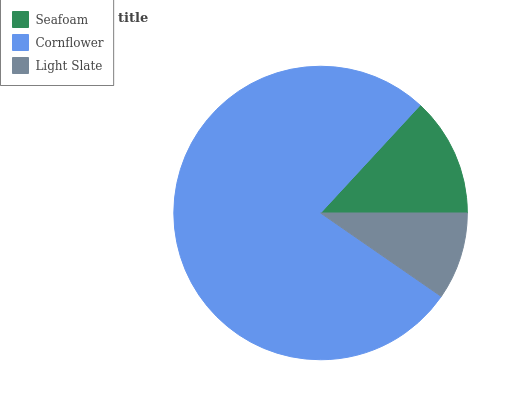Is Light Slate the minimum?
Answer yes or no. Yes. Is Cornflower the maximum?
Answer yes or no. Yes. Is Cornflower the minimum?
Answer yes or no. No. Is Light Slate the maximum?
Answer yes or no. No. Is Cornflower greater than Light Slate?
Answer yes or no. Yes. Is Light Slate less than Cornflower?
Answer yes or no. Yes. Is Light Slate greater than Cornflower?
Answer yes or no. No. Is Cornflower less than Light Slate?
Answer yes or no. No. Is Seafoam the high median?
Answer yes or no. Yes. Is Seafoam the low median?
Answer yes or no. Yes. Is Light Slate the high median?
Answer yes or no. No. Is Cornflower the low median?
Answer yes or no. No. 